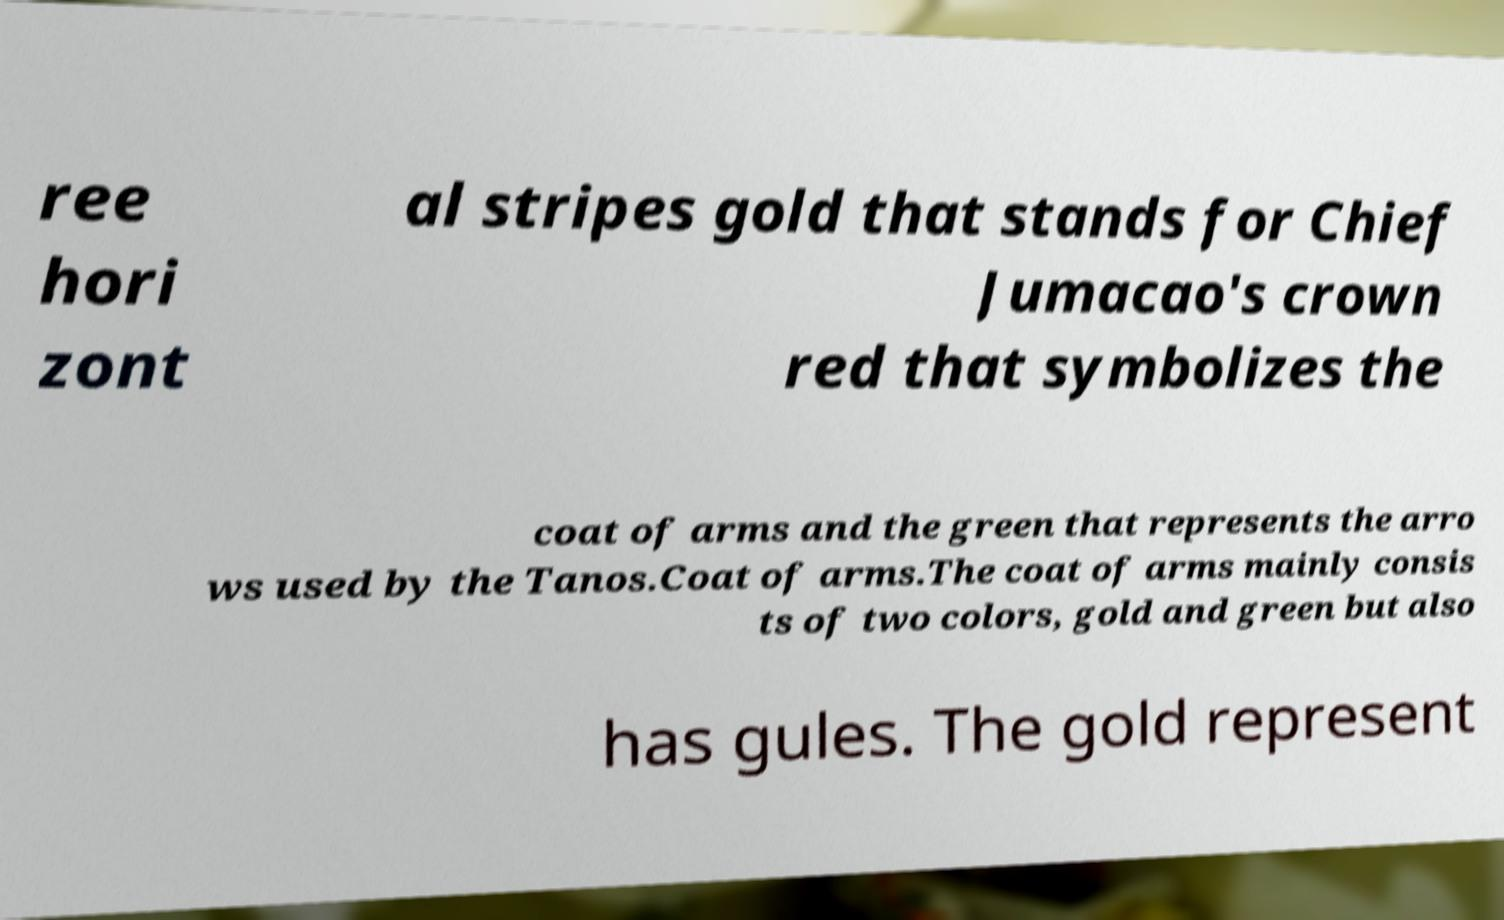I need the written content from this picture converted into text. Can you do that? ree hori zont al stripes gold that stands for Chief Jumacao's crown red that symbolizes the coat of arms and the green that represents the arro ws used by the Tanos.Coat of arms.The coat of arms mainly consis ts of two colors, gold and green but also has gules. The gold represent 